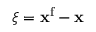Convert formula to latex. <formula><loc_0><loc_0><loc_500><loc_500>\boldsymbol \xi = { x } ^ { f } - { x }</formula> 